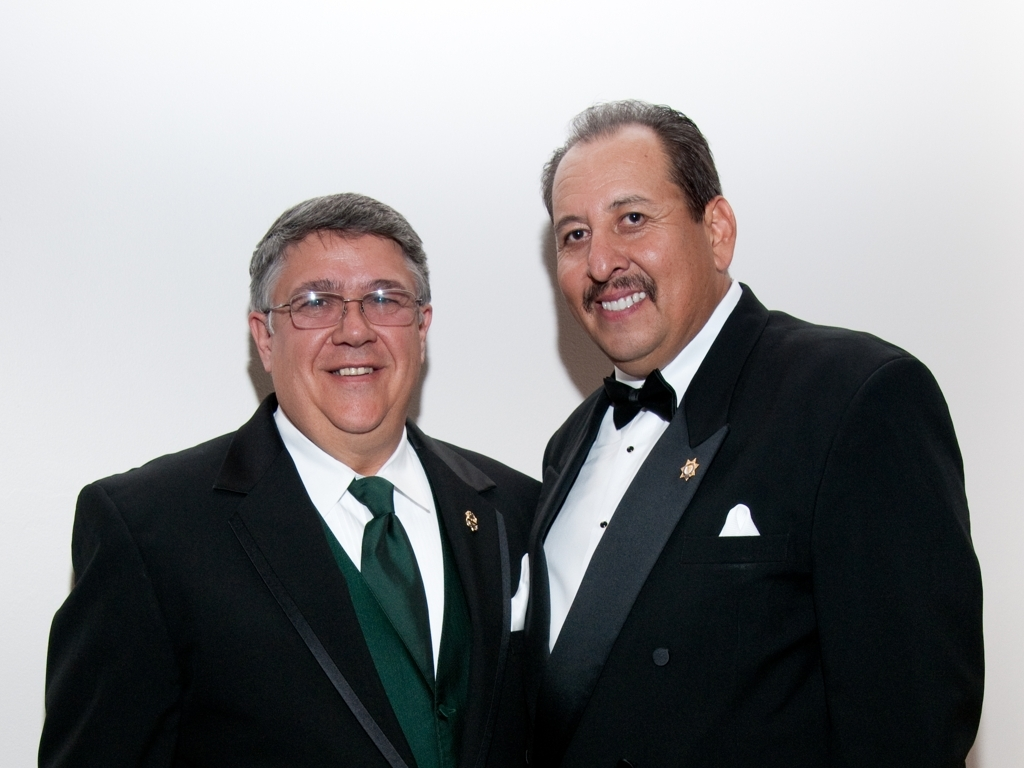What can we infer about their relationship based on this image? Based on their proximity and the positive expressions they share, it's likely that they have a close relationship, such as being good friends, colleagues, or family members. They seem to share a sense of camaraderie and mutual respect. 